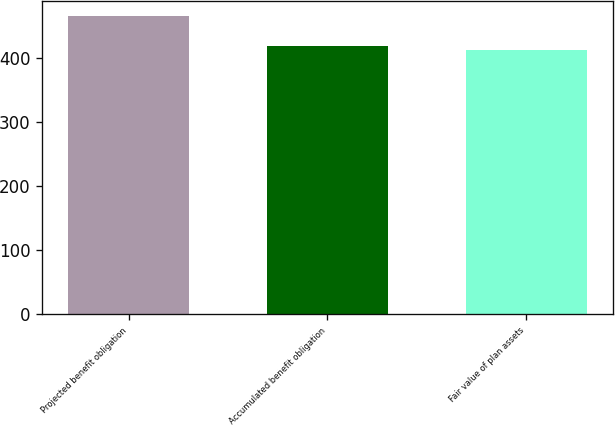<chart> <loc_0><loc_0><loc_500><loc_500><bar_chart><fcel>Projected benefit obligation<fcel>Accumulated benefit obligation<fcel>Fair value of plan assets<nl><fcel>465<fcel>418<fcel>412<nl></chart> 